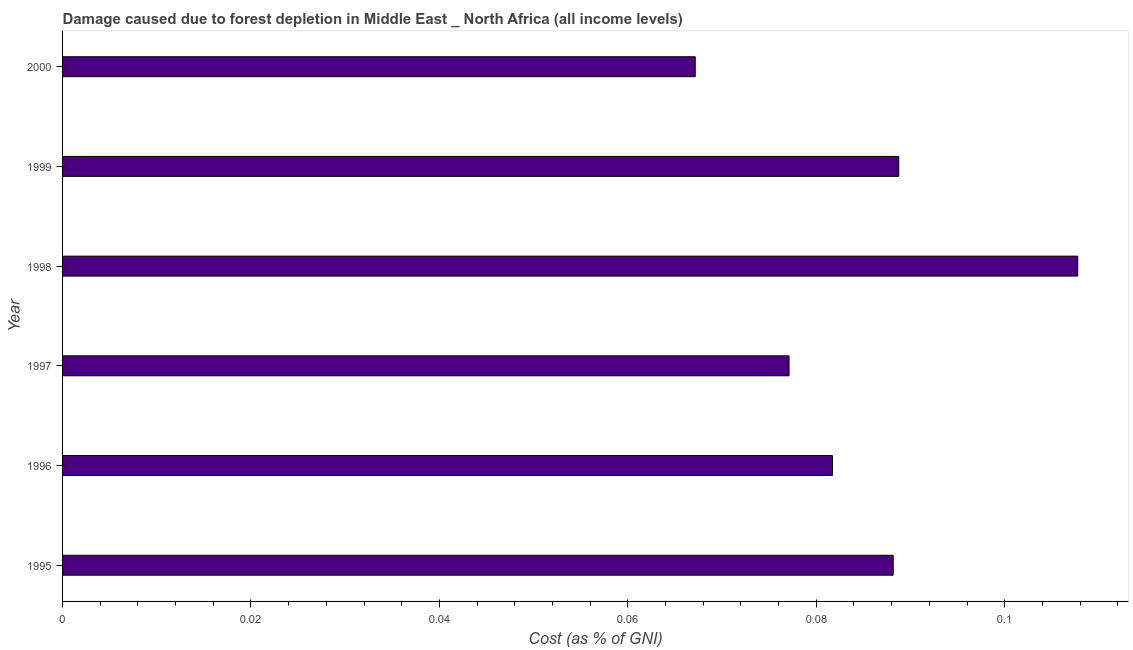Does the graph contain grids?
Provide a short and direct response. No. What is the title of the graph?
Offer a very short reply. Damage caused due to forest depletion in Middle East _ North Africa (all income levels). What is the label or title of the X-axis?
Make the answer very short. Cost (as % of GNI). What is the damage caused due to forest depletion in 2000?
Make the answer very short. 0.07. Across all years, what is the maximum damage caused due to forest depletion?
Provide a short and direct response. 0.11. Across all years, what is the minimum damage caused due to forest depletion?
Give a very brief answer. 0.07. In which year was the damage caused due to forest depletion minimum?
Offer a terse response. 2000. What is the sum of the damage caused due to forest depletion?
Keep it short and to the point. 0.51. What is the difference between the damage caused due to forest depletion in 1996 and 2000?
Offer a terse response. 0.01. What is the average damage caused due to forest depletion per year?
Provide a succinct answer. 0.09. What is the median damage caused due to forest depletion?
Your answer should be very brief. 0.08. What is the ratio of the damage caused due to forest depletion in 1995 to that in 1998?
Make the answer very short. 0.82. Is the difference between the damage caused due to forest depletion in 1997 and 1998 greater than the difference between any two years?
Your answer should be very brief. No. What is the difference between the highest and the second highest damage caused due to forest depletion?
Your answer should be very brief. 0.02. Is the sum of the damage caused due to forest depletion in 1995 and 1997 greater than the maximum damage caused due to forest depletion across all years?
Your answer should be compact. Yes. In how many years, is the damage caused due to forest depletion greater than the average damage caused due to forest depletion taken over all years?
Provide a short and direct response. 3. How many bars are there?
Your answer should be very brief. 6. How many years are there in the graph?
Offer a very short reply. 6. Are the values on the major ticks of X-axis written in scientific E-notation?
Ensure brevity in your answer.  No. What is the Cost (as % of GNI) in 1995?
Offer a very short reply. 0.09. What is the Cost (as % of GNI) in 1996?
Keep it short and to the point. 0.08. What is the Cost (as % of GNI) of 1997?
Your response must be concise. 0.08. What is the Cost (as % of GNI) in 1998?
Give a very brief answer. 0.11. What is the Cost (as % of GNI) in 1999?
Give a very brief answer. 0.09. What is the Cost (as % of GNI) in 2000?
Your response must be concise. 0.07. What is the difference between the Cost (as % of GNI) in 1995 and 1996?
Give a very brief answer. 0.01. What is the difference between the Cost (as % of GNI) in 1995 and 1997?
Offer a very short reply. 0.01. What is the difference between the Cost (as % of GNI) in 1995 and 1998?
Your response must be concise. -0.02. What is the difference between the Cost (as % of GNI) in 1995 and 1999?
Provide a succinct answer. -0. What is the difference between the Cost (as % of GNI) in 1995 and 2000?
Offer a terse response. 0.02. What is the difference between the Cost (as % of GNI) in 1996 and 1997?
Provide a succinct answer. 0. What is the difference between the Cost (as % of GNI) in 1996 and 1998?
Give a very brief answer. -0.03. What is the difference between the Cost (as % of GNI) in 1996 and 1999?
Offer a terse response. -0.01. What is the difference between the Cost (as % of GNI) in 1996 and 2000?
Offer a terse response. 0.01. What is the difference between the Cost (as % of GNI) in 1997 and 1998?
Make the answer very short. -0.03. What is the difference between the Cost (as % of GNI) in 1997 and 1999?
Give a very brief answer. -0.01. What is the difference between the Cost (as % of GNI) in 1997 and 2000?
Provide a succinct answer. 0.01. What is the difference between the Cost (as % of GNI) in 1998 and 1999?
Make the answer very short. 0.02. What is the difference between the Cost (as % of GNI) in 1998 and 2000?
Provide a short and direct response. 0.04. What is the difference between the Cost (as % of GNI) in 1999 and 2000?
Keep it short and to the point. 0.02. What is the ratio of the Cost (as % of GNI) in 1995 to that in 1996?
Offer a terse response. 1.08. What is the ratio of the Cost (as % of GNI) in 1995 to that in 1997?
Your answer should be compact. 1.14. What is the ratio of the Cost (as % of GNI) in 1995 to that in 1998?
Offer a very short reply. 0.82. What is the ratio of the Cost (as % of GNI) in 1995 to that in 2000?
Your answer should be very brief. 1.31. What is the ratio of the Cost (as % of GNI) in 1996 to that in 1997?
Give a very brief answer. 1.06. What is the ratio of the Cost (as % of GNI) in 1996 to that in 1998?
Your response must be concise. 0.76. What is the ratio of the Cost (as % of GNI) in 1996 to that in 1999?
Your response must be concise. 0.92. What is the ratio of the Cost (as % of GNI) in 1996 to that in 2000?
Ensure brevity in your answer.  1.22. What is the ratio of the Cost (as % of GNI) in 1997 to that in 1998?
Provide a short and direct response. 0.72. What is the ratio of the Cost (as % of GNI) in 1997 to that in 1999?
Your response must be concise. 0.87. What is the ratio of the Cost (as % of GNI) in 1997 to that in 2000?
Provide a succinct answer. 1.15. What is the ratio of the Cost (as % of GNI) in 1998 to that in 1999?
Make the answer very short. 1.21. What is the ratio of the Cost (as % of GNI) in 1998 to that in 2000?
Give a very brief answer. 1.6. What is the ratio of the Cost (as % of GNI) in 1999 to that in 2000?
Ensure brevity in your answer.  1.32. 